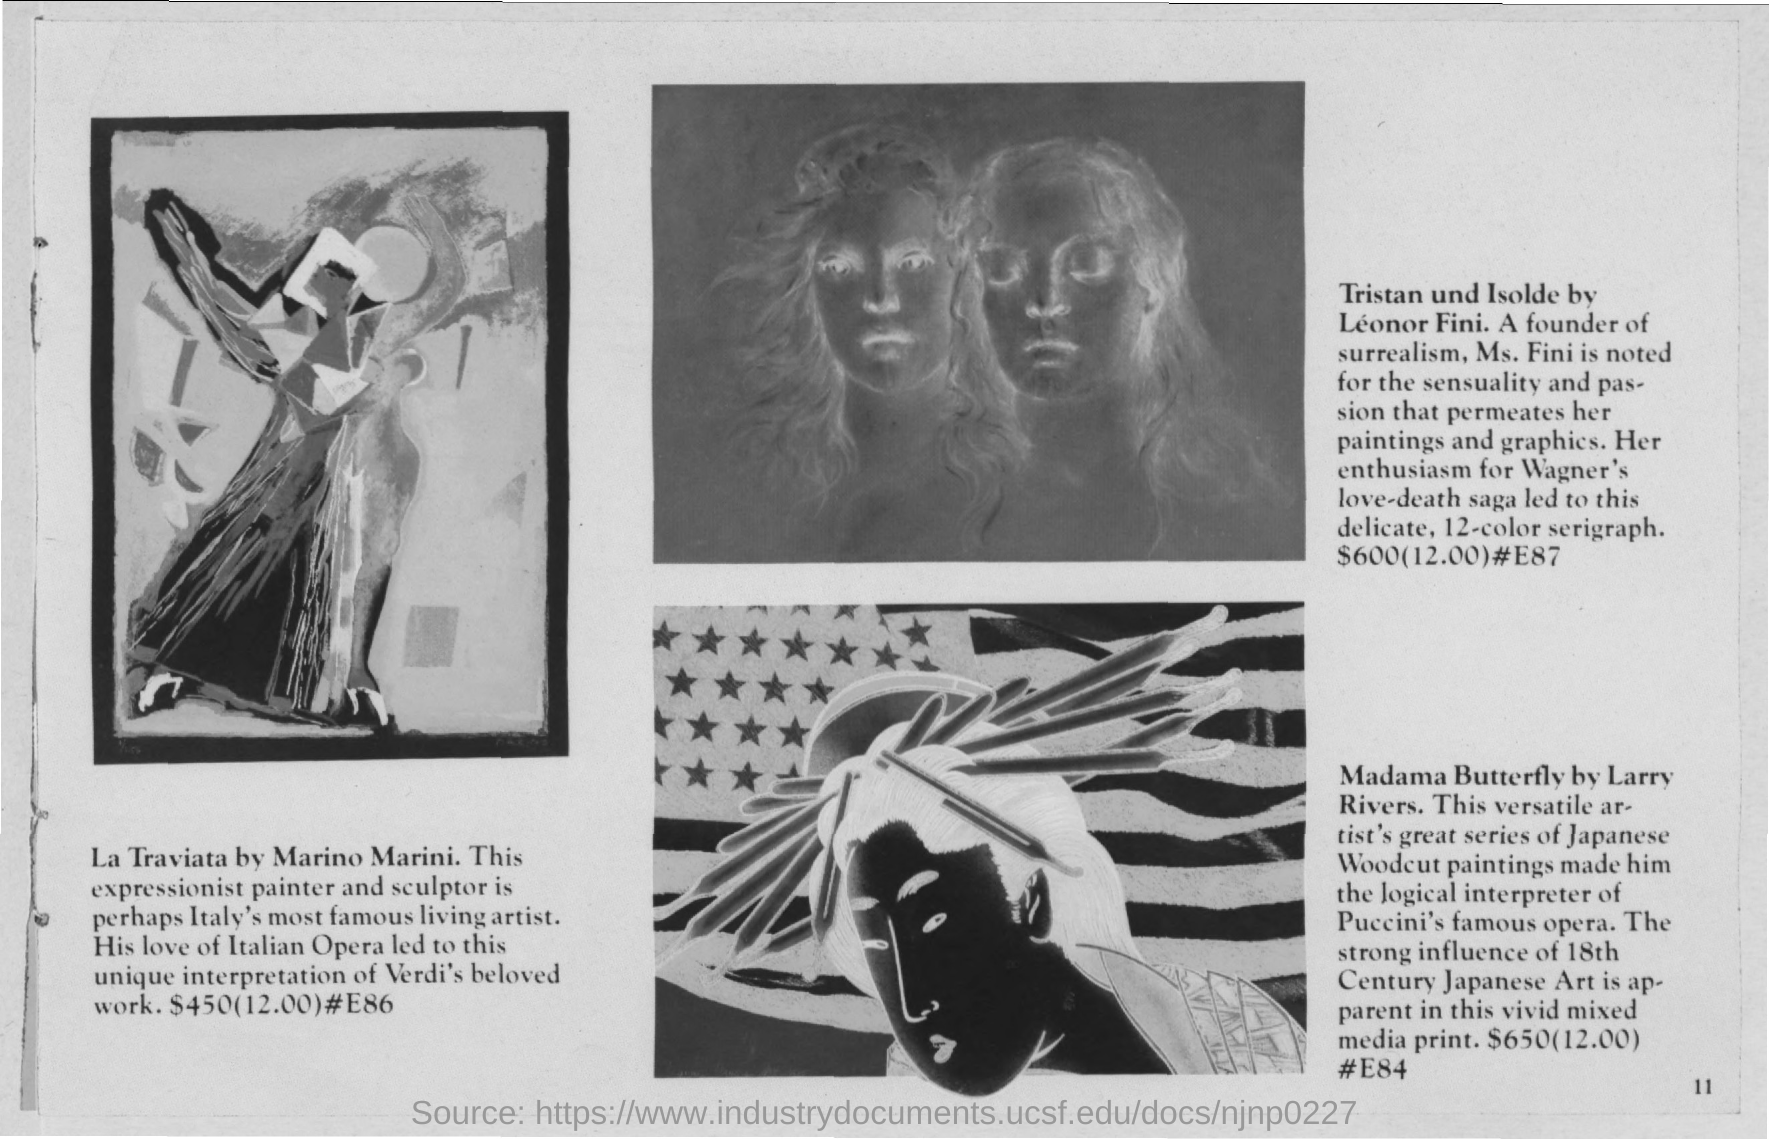Who painted the artwork La Traviata?
Make the answer very short. Marino Marini. Which work of Leonor Fini is shown here?
Give a very brief answer. Tristan und Isolde. Whose painting is the Madama Butterfly?
Provide a succinct answer. LARRY RIVERS. What is the price of La Traviata?
Your answer should be compact. $450. 